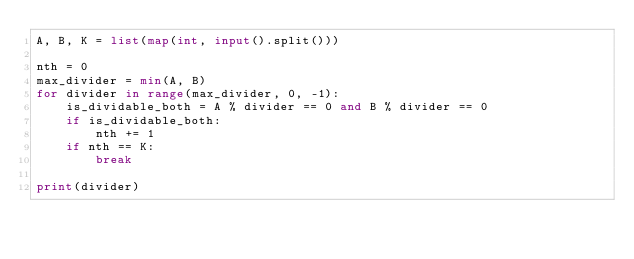<code> <loc_0><loc_0><loc_500><loc_500><_Python_>A, B, K = list(map(int, input().split()))

nth = 0
max_divider = min(A, B)
for divider in range(max_divider, 0, -1):
    is_dividable_both = A % divider == 0 and B % divider == 0
    if is_dividable_both:
        nth += 1
    if nth == K:
        break

print(divider)
</code> 